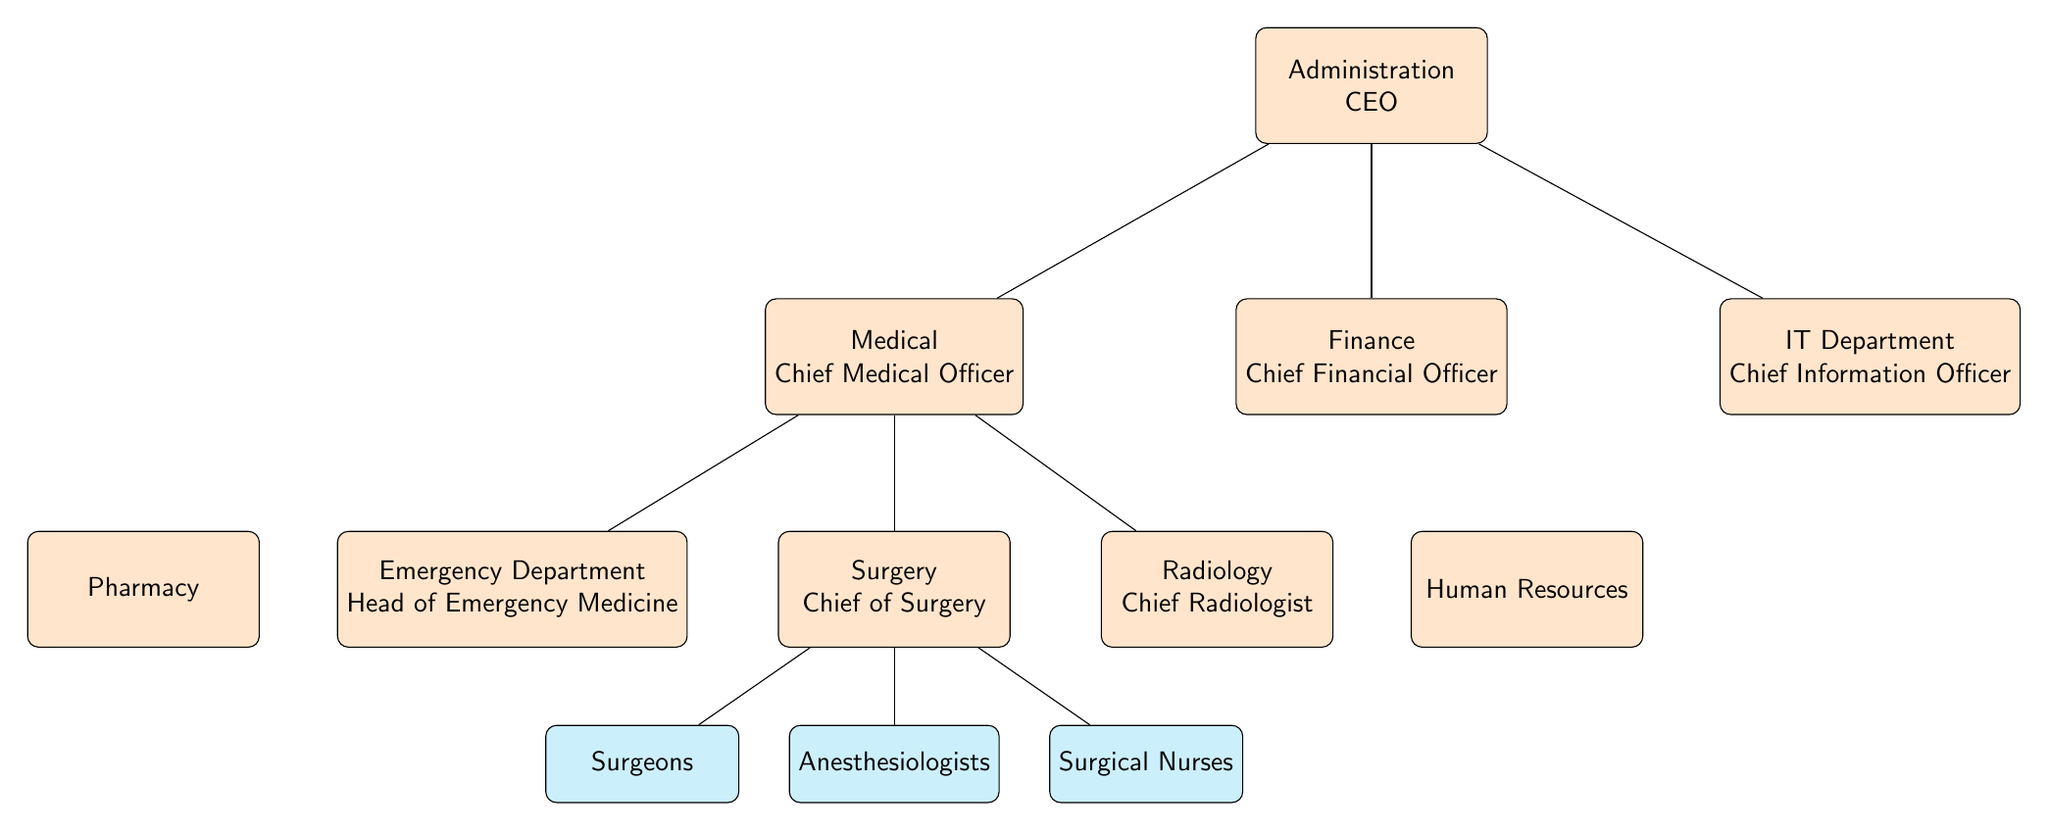What is the title of the top node in the diagram? The top node is labeled "Administration" and "CEO". It is the highest level in the organizational structure, indicating the main leadership role in the healthcare facility.
Answer: Administration CEO How many departments are directly below the CEO? There are three departments directly below the CEO node: the Medical department led by the Chief Medical Officer, the Finance department led by the Chief Financial Officer, and the IT department led by the Chief Information Officer.
Answer: 3 Which role is directly under the Chief of Surgery? The role directly under the Chief of Surgery is "Surgeons". This indicates that surgeons operate as a separate team managed by the chief in the surgical department.
Answer: Surgeons What department is located to the left of the Emergency Department? The department located to the left of the Emergency Department is "Pharmacy". This shows the layout of departments across the diagram, indicating their relative positions.
Answer: Pharmacy Who reports directly to the Chief Medical Officer? Three roles report directly to the Chief Medical Officer: Head of Emergency Medicine, Chief of Surgery, and Chief Radiologist. This indicates the CMO's direct oversight over these critical areas of the facility.
Answer: Head of Emergency Medicine, Chief of Surgery, Chief Radiologist How many roles are under the Chief of Surgery? There are three roles under the Chief of Surgery: Surgeons, Anesthesiologists, and Surgical Nurses. This indicates the team composition within the surgical department.
Answer: 3 What is the relationship between the Chief Medical Officer and the Chief Financial Officer? The relationship is that both are separate departments directly reporting to the CEO. They are on the same level in the organizational hierarchy, indicating they are peers.
Answer: Peer relationship Which department is located to the right of the Chief Radiologist? The department located to the right of the Chief Radiologist is "Human Resources". This shows the spatial arrangement of these departments on the diagram.
Answer: Human Resources 